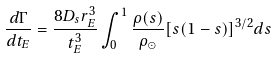Convert formula to latex. <formula><loc_0><loc_0><loc_500><loc_500>\frac { d \Gamma } { d t _ { E } } = \frac { 8 D _ { s } r _ { E } ^ { 3 } } { t _ { E } ^ { 3 } } \int _ { 0 } ^ { 1 } { \frac { \rho ( s ) } { \rho _ { \odot } } [ s ( 1 - s ) ] ^ { 3 / 2 } d s }</formula> 